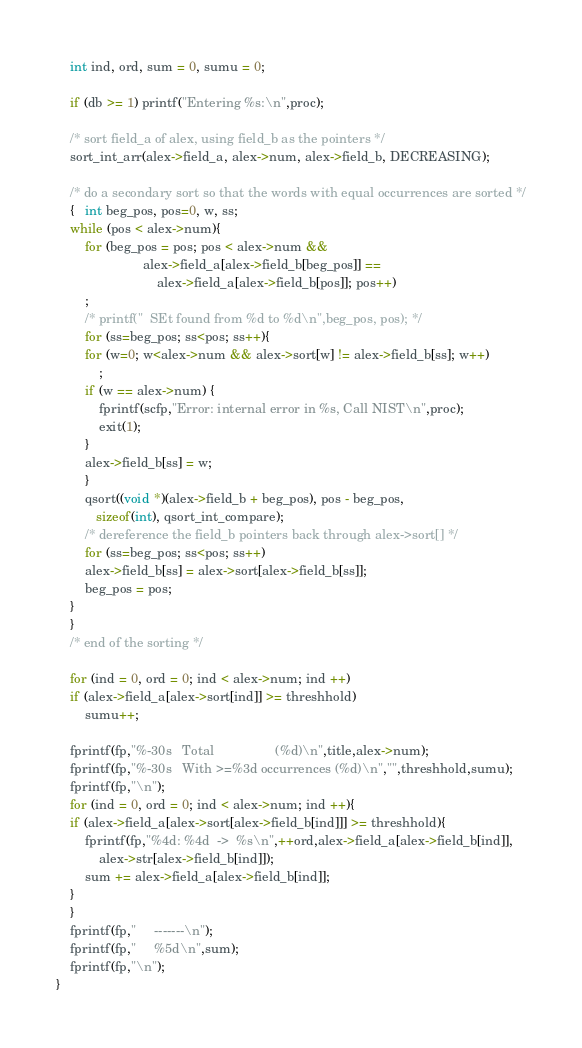Convert code to text. <code><loc_0><loc_0><loc_500><loc_500><_C_>    int ind, ord, sum = 0, sumu = 0;

    if (db >= 1) printf("Entering %s:\n",proc);

    /* sort field_a of alex, using field_b as the pointers */
    sort_int_arr(alex->field_a, alex->num, alex->field_b, DECREASING);

    /* do a secondary sort so that the words with equal occurrences are sorted */
    {   int beg_pos, pos=0, w, ss;
	while (pos < alex->num){
	    for (beg_pos = pos; pos < alex->num && 
		                alex->field_a[alex->field_b[beg_pos]] ==
		                    alex->field_a[alex->field_b[pos]]; pos++)
		;
	    /* printf("  SEt found from %d to %d\n",beg_pos, pos); */
	    for (ss=beg_pos; ss<pos; ss++){
		for (w=0; w<alex->num && alex->sort[w] != alex->field_b[ss]; w++)
		    ;
		if (w == alex->num) {
		    fprintf(scfp,"Error: internal error in %s, Call NIST\n",proc);
		    exit(1);
		}
		alex->field_b[ss] = w;
	    }	    
	    qsort((void *)(alex->field_b + beg_pos), pos - beg_pos,
		   sizeof(int), qsort_int_compare);
	    /* dereference the field_b pointers back through alex->sort[] */
	    for (ss=beg_pos; ss<pos; ss++)
		alex->field_b[ss] = alex->sort[alex->field_b[ss]];
	    beg_pos = pos;
	}
    }
    /* end of the sorting */

    for (ind = 0, ord = 0; ind < alex->num; ind ++)
	if (alex->field_a[alex->sort[ind]] >= threshhold)
	    sumu++;
    
    fprintf(fp,"%-30s   Total                 (%d)\n",title,alex->num);
    fprintf(fp,"%-30s   With >=%3d occurrences (%d)\n","",threshhold,sumu);
    fprintf(fp,"\n");
    for (ind = 0, ord = 0; ind < alex->num; ind ++){
	if (alex->field_a[alex->sort[alex->field_b[ind]]] >= threshhold){
	    fprintf(fp,"%4d: %4d  ->  %s\n",++ord,alex->field_a[alex->field_b[ind]],
		    alex->str[alex->field_b[ind]]);
	    sum += alex->field_a[alex->field_b[ind]];
	}
    }
    fprintf(fp,"     -------\n");
    fprintf(fp,"     %5d\n",sum);
    fprintf(fp,"\n");
}







</code> 